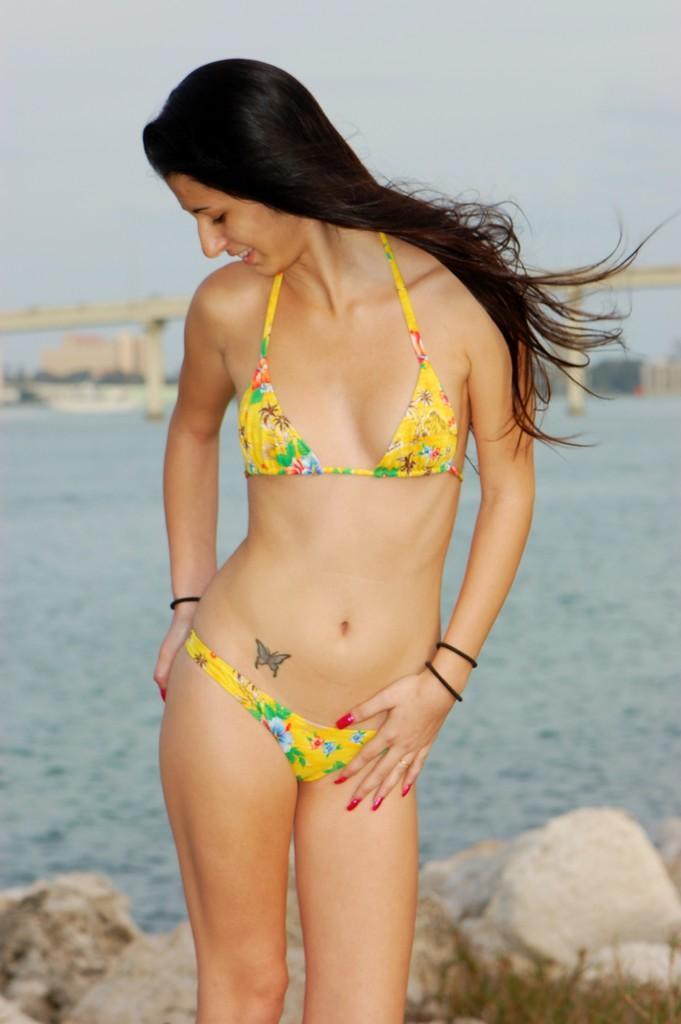Can you describe this image briefly? In this image we can see a woman standing on the ground. In the background we can see bridge, sky, water, buildings and rocks. 